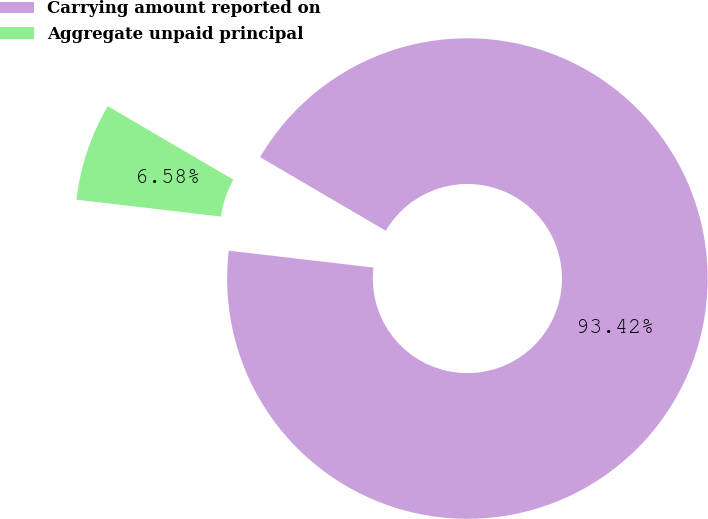<chart> <loc_0><loc_0><loc_500><loc_500><pie_chart><fcel>Carrying amount reported on<fcel>Aggregate unpaid principal<nl><fcel>93.42%<fcel>6.58%<nl></chart> 